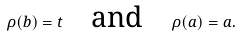Convert formula to latex. <formula><loc_0><loc_0><loc_500><loc_500>\rho ( b ) = t \quad \text {and} \quad \rho ( a ) = a .</formula> 